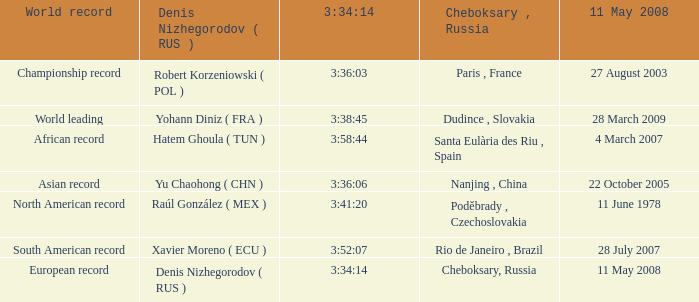When 3:41:20 is  3:34:14 what is cheboksary , russia? Poděbrady , Czechoslovakia. 